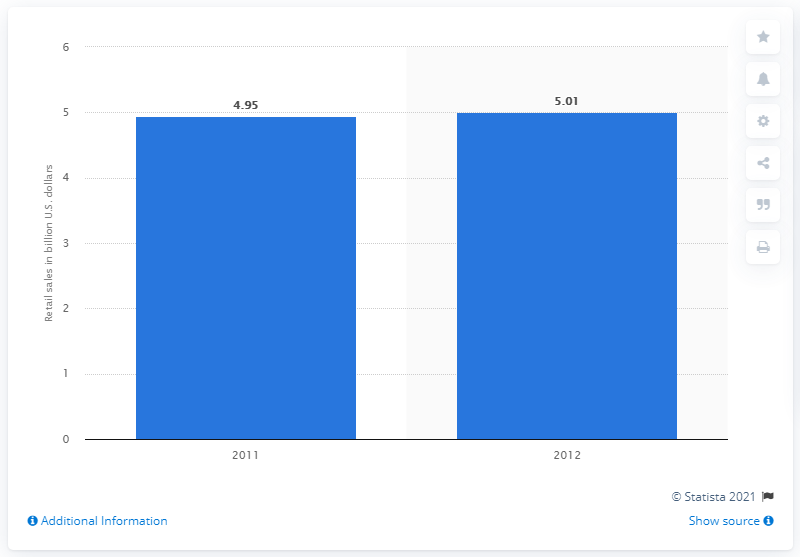List a handful of essential elements in this visual. In 2011, the total amount of lawn and garden retail sales at garden center outlets was 4.95 billion dollars. 